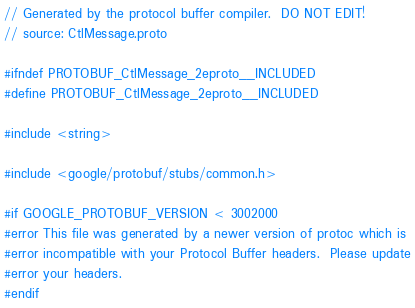Convert code to text. <code><loc_0><loc_0><loc_500><loc_500><_C_>// Generated by the protocol buffer compiler.  DO NOT EDIT!
// source: CtlMessage.proto

#ifndef PROTOBUF_CtlMessage_2eproto__INCLUDED
#define PROTOBUF_CtlMessage_2eproto__INCLUDED

#include <string>

#include <google/protobuf/stubs/common.h>

#if GOOGLE_PROTOBUF_VERSION < 3002000
#error This file was generated by a newer version of protoc which is
#error incompatible with your Protocol Buffer headers.  Please update
#error your headers.
#endif</code> 